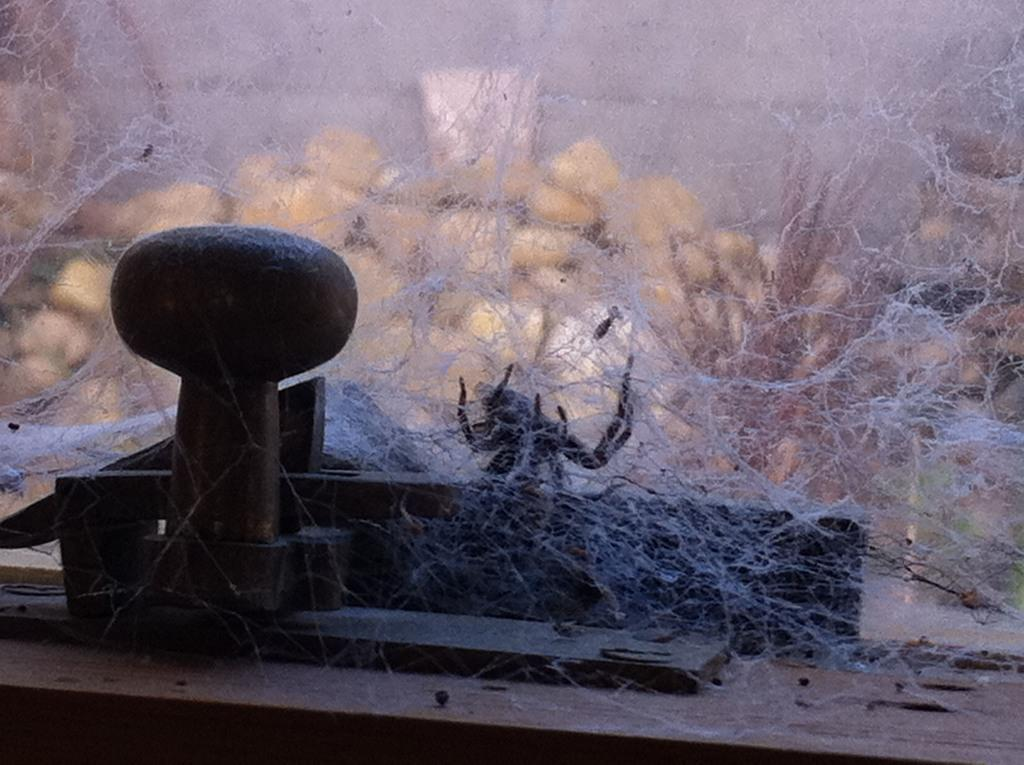What type of creature is present in the image? There is a spider in the image. What does the spider create to catch its prey? The spider's web is visible in the image. What object can be seen on the left side of the image? There is an iron-like object on the left side of the image. Is there a swing visible in the image? No, there is no swing present in the image. What time of day is depicted in the image? The time of day is not mentioned in the provided facts, so it cannot be determined from the image. 